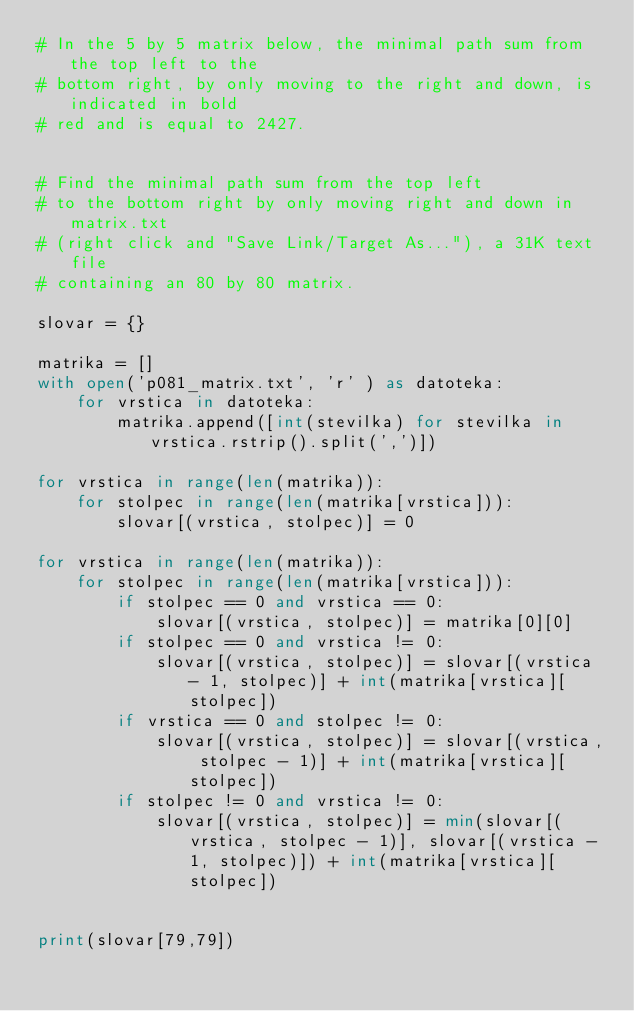Convert code to text. <code><loc_0><loc_0><loc_500><loc_500><_Python_># In the 5 by 5 matrix below, the minimal path sum from the top left to the 
# bottom right, by only moving to the right and down, is indicated in bold 
# red and is equal to 2427.

 
# Find the minimal path sum from the top left 
# to the bottom right by only moving right and down in matrix.txt 
# (right click and "Save Link/Target As..."), a 31K text file 
# containing an 80 by 80 matrix.

slovar = {}

matrika = []
with open('p081_matrix.txt', 'r' ) as datoteka:
    for vrstica in datoteka:
        matrika.append([int(stevilka) for stevilka in vrstica.rstrip().split(',')])
     
for vrstica in range(len(matrika)):
    for stolpec in range(len(matrika[vrstica])):
        slovar[(vrstica, stolpec)] = 0
        
for vrstica in range(len(matrika)):
    for stolpec in range(len(matrika[vrstica])):
        if stolpec == 0 and vrstica == 0:
            slovar[(vrstica, stolpec)] = matrika[0][0]
        if stolpec == 0 and vrstica != 0:
            slovar[(vrstica, stolpec)] = slovar[(vrstica - 1, stolpec)] + int(matrika[vrstica][stolpec])
        if vrstica == 0 and stolpec != 0:       
            slovar[(vrstica, stolpec)] = slovar[(vrstica, stolpec - 1)] + int(matrika[vrstica][stolpec])
        if stolpec != 0 and vrstica != 0:
            slovar[(vrstica, stolpec)] = min(slovar[(vrstica, stolpec - 1)], slovar[(vrstica - 1, stolpec)]) + int(matrika[vrstica][stolpec])


print(slovar[79,79])
</code> 